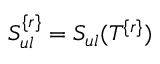<formula> <loc_0><loc_0><loc_500><loc_500>S _ { u l } ^ { \{ r \} } = S _ { u l } ( T ^ { \{ r \} } )</formula> 